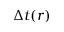<formula> <loc_0><loc_0><loc_500><loc_500>\Delta t ( r )</formula> 